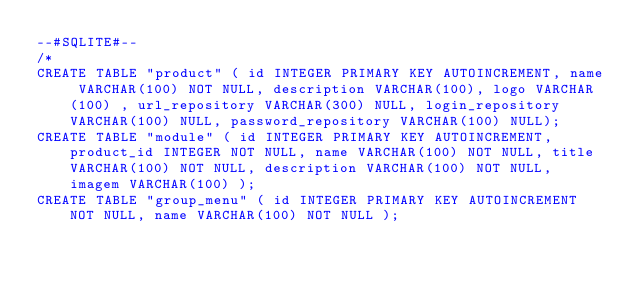Convert code to text. <code><loc_0><loc_0><loc_500><loc_500><_SQL_>--#SQLITE#--
/*
CREATE TABLE "product" ( id INTEGER PRIMARY KEY AUTOINCREMENT, name VARCHAR(100) NOT NULL, description VARCHAR(100), logo VARCHAR(100) , url_repository VARCHAR(300) NULL, login_repository VARCHAR(100) NULL, password_repository VARCHAR(100) NULL);
CREATE TABLE "module" ( id INTEGER PRIMARY KEY AUTOINCREMENT, product_id INTEGER NOT NULL, name VARCHAR(100) NOT NULL, title VARCHAR(100) NOT NULL, description VARCHAR(100) NOT NULL, imagem VARCHAR(100) );
CREATE TABLE "group_menu" ( id INTEGER PRIMARY KEY AUTOINCREMENT NOT NULL, name VARCHAR(100) NOT NULL );</code> 